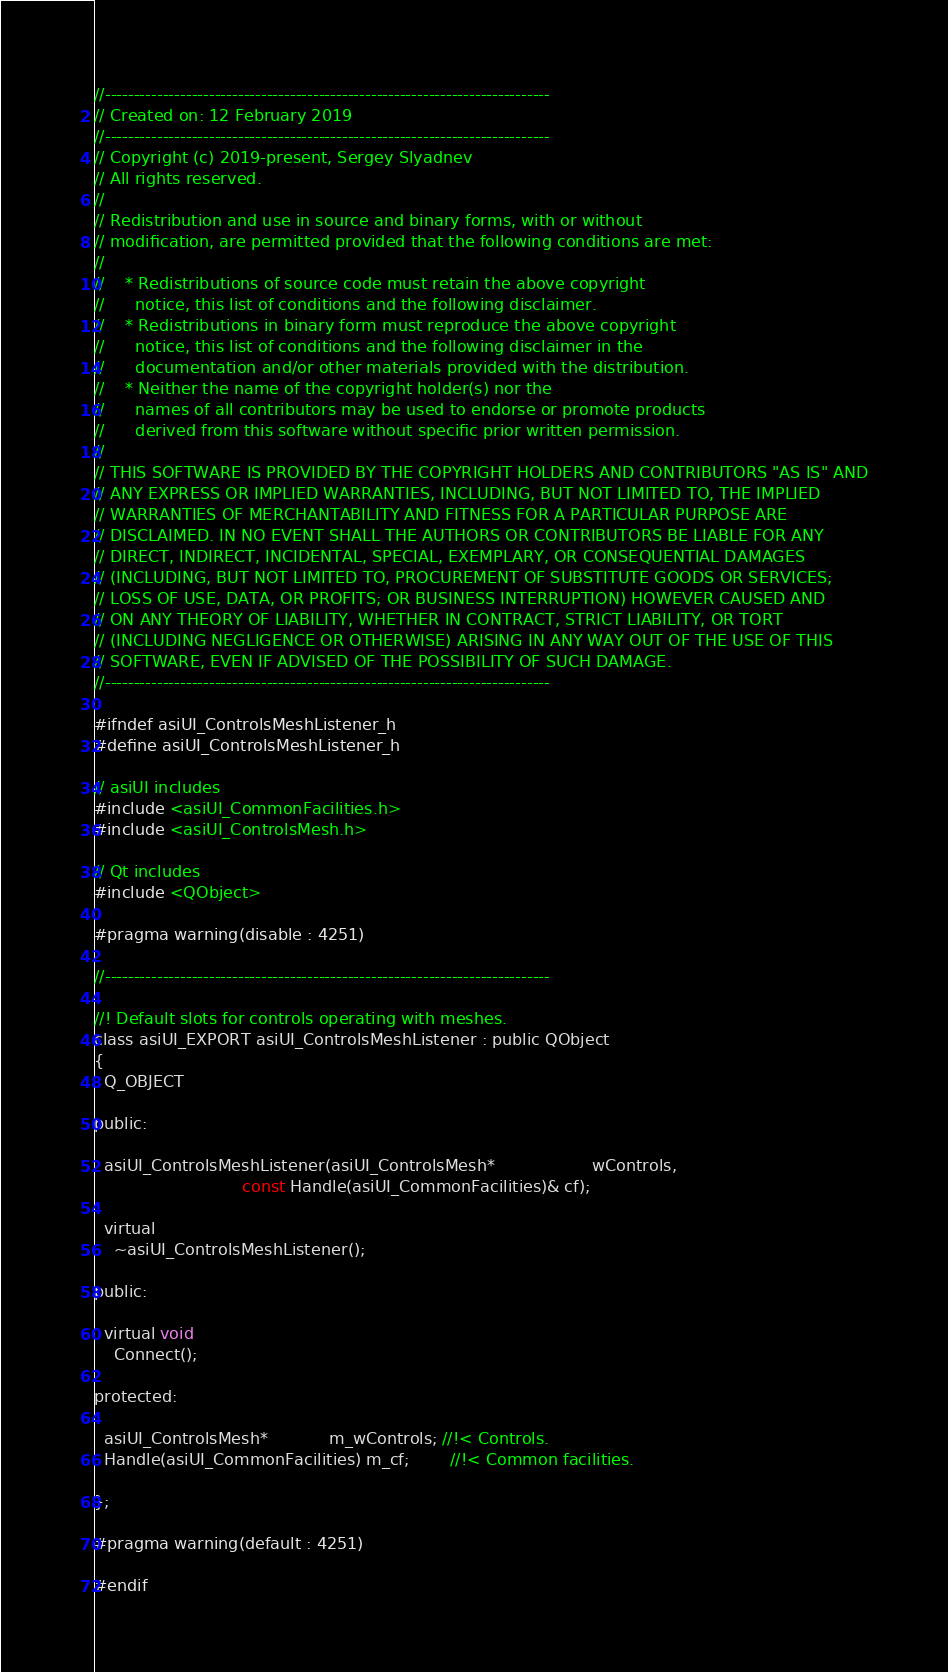Convert code to text. <code><loc_0><loc_0><loc_500><loc_500><_C_>//-----------------------------------------------------------------------------
// Created on: 12 February 2019
//-----------------------------------------------------------------------------
// Copyright (c) 2019-present, Sergey Slyadnev
// All rights reserved.
//
// Redistribution and use in source and binary forms, with or without
// modification, are permitted provided that the following conditions are met:
//
//    * Redistributions of source code must retain the above copyright
//      notice, this list of conditions and the following disclaimer.
//    * Redistributions in binary form must reproduce the above copyright
//      notice, this list of conditions and the following disclaimer in the
//      documentation and/or other materials provided with the distribution.
//    * Neither the name of the copyright holder(s) nor the
//      names of all contributors may be used to endorse or promote products
//      derived from this software without specific prior written permission.
//
// THIS SOFTWARE IS PROVIDED BY THE COPYRIGHT HOLDERS AND CONTRIBUTORS "AS IS" AND
// ANY EXPRESS OR IMPLIED WARRANTIES, INCLUDING, BUT NOT LIMITED TO, THE IMPLIED
// WARRANTIES OF MERCHANTABILITY AND FITNESS FOR A PARTICULAR PURPOSE ARE
// DISCLAIMED. IN NO EVENT SHALL THE AUTHORS OR CONTRIBUTORS BE LIABLE FOR ANY
// DIRECT, INDIRECT, INCIDENTAL, SPECIAL, EXEMPLARY, OR CONSEQUENTIAL DAMAGES
// (INCLUDING, BUT NOT LIMITED TO, PROCUREMENT OF SUBSTITUTE GOODS OR SERVICES;
// LOSS OF USE, DATA, OR PROFITS; OR BUSINESS INTERRUPTION) HOWEVER CAUSED AND
// ON ANY THEORY OF LIABILITY, WHETHER IN CONTRACT, STRICT LIABILITY, OR TORT
// (INCLUDING NEGLIGENCE OR OTHERWISE) ARISING IN ANY WAY OUT OF THE USE OF THIS
// SOFTWARE, EVEN IF ADVISED OF THE POSSIBILITY OF SUCH DAMAGE.
//-----------------------------------------------------------------------------

#ifndef asiUI_ControlsMeshListener_h
#define asiUI_ControlsMeshListener_h

// asiUI includes
#include <asiUI_CommonFacilities.h>
#include <asiUI_ControlsMesh.h>

// Qt includes
#include <QObject>

#pragma warning(disable : 4251)

//-----------------------------------------------------------------------------

//! Default slots for controls operating with meshes.
class asiUI_EXPORT asiUI_ControlsMeshListener : public QObject
{
  Q_OBJECT

public:

  asiUI_ControlsMeshListener(asiUI_ControlsMesh*                   wControls,
                             const Handle(asiUI_CommonFacilities)& cf);

  virtual
    ~asiUI_ControlsMeshListener();

public:

  virtual void
    Connect();

protected:

  asiUI_ControlsMesh*            m_wControls; //!< Controls.
  Handle(asiUI_CommonFacilities) m_cf;        //!< Common facilities.

};

#pragma warning(default : 4251)

#endif
</code> 